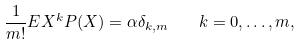<formula> <loc_0><loc_0><loc_500><loc_500>\frac { 1 } { m ! } E X ^ { k } P ( X ) = \alpha \delta _ { k , m } \quad k = 0 , \dots , m ,</formula> 